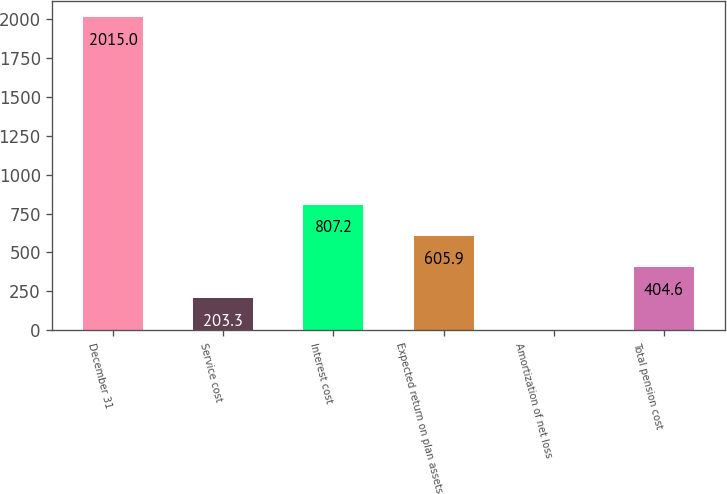Convert chart to OTSL. <chart><loc_0><loc_0><loc_500><loc_500><bar_chart><fcel>December 31<fcel>Service cost<fcel>Interest cost<fcel>Expected return on plan assets<fcel>Amortization of net loss<fcel>Total pension cost<nl><fcel>2015<fcel>203.3<fcel>807.2<fcel>605.9<fcel>2<fcel>404.6<nl></chart> 